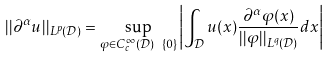<formula> <loc_0><loc_0><loc_500><loc_500>| | \partial ^ { \alpha } u | | _ { L ^ { p } ( \mathcal { D } ) } = \sup _ { \varphi \in C _ { c } ^ { \infty } ( \mathcal { D } ) \ \{ 0 \} } \left | \int _ { \mathcal { D } } u ( x ) \frac { \partial ^ { \alpha } \varphi ( x ) } { | | \varphi | | _ { L ^ { q } ( \mathcal { D } ) } } d x \right |</formula> 